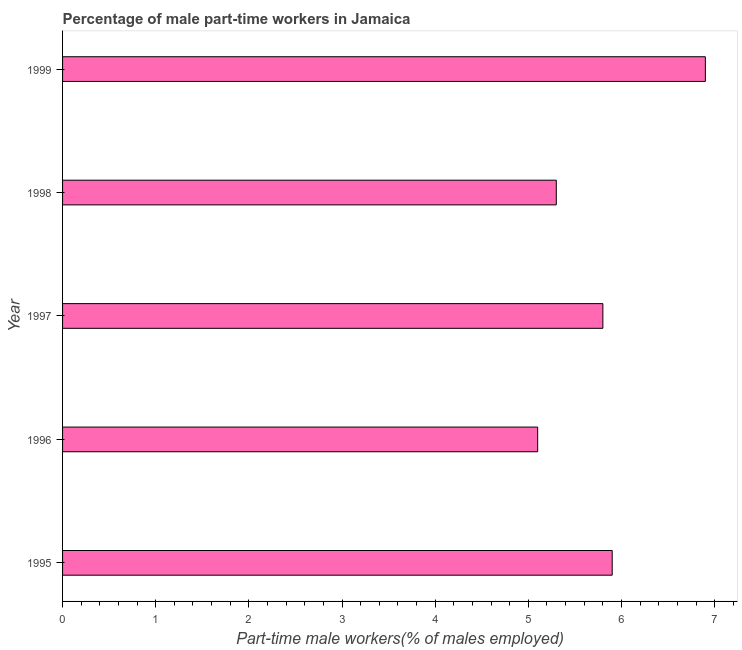What is the title of the graph?
Keep it short and to the point. Percentage of male part-time workers in Jamaica. What is the label or title of the X-axis?
Offer a very short reply. Part-time male workers(% of males employed). What is the percentage of part-time male workers in 1998?
Offer a very short reply. 5.3. Across all years, what is the maximum percentage of part-time male workers?
Offer a terse response. 6.9. Across all years, what is the minimum percentage of part-time male workers?
Keep it short and to the point. 5.1. What is the sum of the percentage of part-time male workers?
Give a very brief answer. 29. What is the median percentage of part-time male workers?
Make the answer very short. 5.8. In how many years, is the percentage of part-time male workers greater than 4.8 %?
Ensure brevity in your answer.  5. What is the ratio of the percentage of part-time male workers in 1995 to that in 1996?
Offer a terse response. 1.16. Is the sum of the percentage of part-time male workers in 1995 and 1997 greater than the maximum percentage of part-time male workers across all years?
Give a very brief answer. Yes. What is the difference between the highest and the lowest percentage of part-time male workers?
Give a very brief answer. 1.8. How many bars are there?
Your answer should be compact. 5. Are all the bars in the graph horizontal?
Give a very brief answer. Yes. How many years are there in the graph?
Offer a terse response. 5. What is the Part-time male workers(% of males employed) of 1995?
Give a very brief answer. 5.9. What is the Part-time male workers(% of males employed) in 1996?
Give a very brief answer. 5.1. What is the Part-time male workers(% of males employed) in 1997?
Provide a short and direct response. 5.8. What is the Part-time male workers(% of males employed) in 1998?
Give a very brief answer. 5.3. What is the Part-time male workers(% of males employed) in 1999?
Make the answer very short. 6.9. What is the difference between the Part-time male workers(% of males employed) in 1995 and 1998?
Give a very brief answer. 0.6. What is the difference between the Part-time male workers(% of males employed) in 1995 and 1999?
Offer a very short reply. -1. What is the difference between the Part-time male workers(% of males employed) in 1996 and 1997?
Ensure brevity in your answer.  -0.7. What is the ratio of the Part-time male workers(% of males employed) in 1995 to that in 1996?
Ensure brevity in your answer.  1.16. What is the ratio of the Part-time male workers(% of males employed) in 1995 to that in 1998?
Your response must be concise. 1.11. What is the ratio of the Part-time male workers(% of males employed) in 1995 to that in 1999?
Your answer should be compact. 0.85. What is the ratio of the Part-time male workers(% of males employed) in 1996 to that in 1997?
Ensure brevity in your answer.  0.88. What is the ratio of the Part-time male workers(% of males employed) in 1996 to that in 1998?
Your answer should be compact. 0.96. What is the ratio of the Part-time male workers(% of males employed) in 1996 to that in 1999?
Give a very brief answer. 0.74. What is the ratio of the Part-time male workers(% of males employed) in 1997 to that in 1998?
Give a very brief answer. 1.09. What is the ratio of the Part-time male workers(% of males employed) in 1997 to that in 1999?
Your answer should be compact. 0.84. What is the ratio of the Part-time male workers(% of males employed) in 1998 to that in 1999?
Your answer should be very brief. 0.77. 